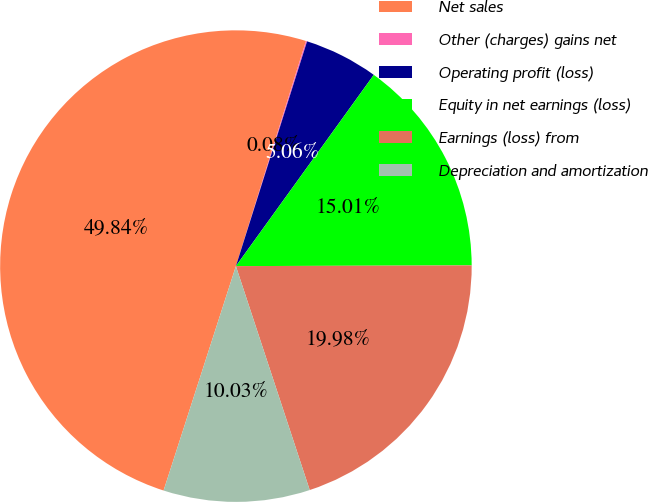<chart> <loc_0><loc_0><loc_500><loc_500><pie_chart><fcel>Net sales<fcel>Other (charges) gains net<fcel>Operating profit (loss)<fcel>Equity in net earnings (loss)<fcel>Earnings (loss) from<fcel>Depreciation and amortization<nl><fcel>49.84%<fcel>0.08%<fcel>5.06%<fcel>15.01%<fcel>19.98%<fcel>10.03%<nl></chart> 